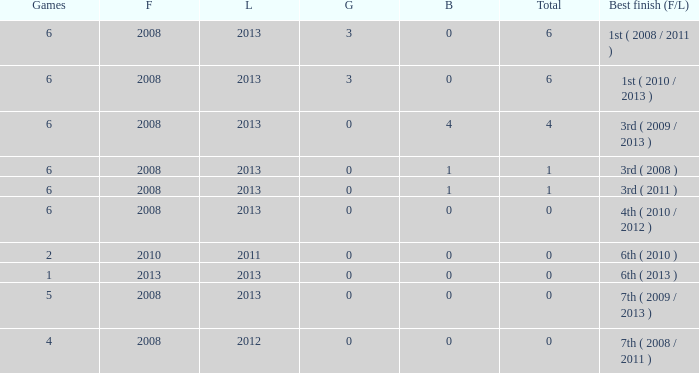How many bronzes associated with over 0 total medals, 3 golds, and over 6 games? None. 